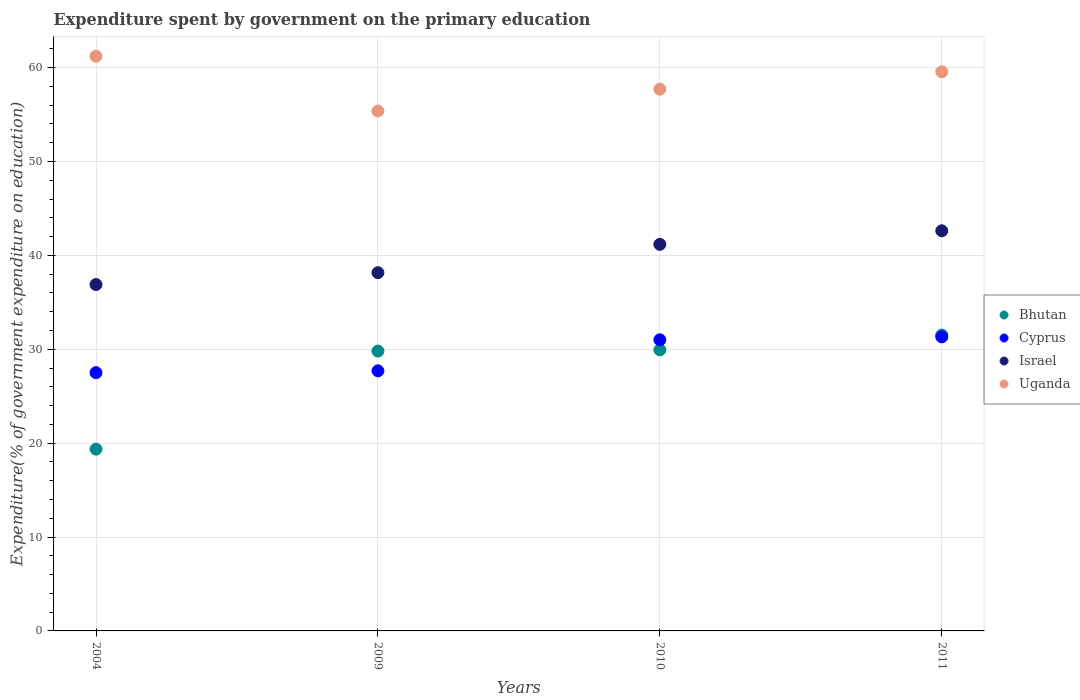What is the expenditure spent by government on the primary education in Uganda in 2004?
Provide a succinct answer. 61.21. Across all years, what is the maximum expenditure spent by government on the primary education in Uganda?
Provide a short and direct response. 61.21. Across all years, what is the minimum expenditure spent by government on the primary education in Israel?
Provide a short and direct response. 36.89. What is the total expenditure spent by government on the primary education in Uganda in the graph?
Ensure brevity in your answer.  233.84. What is the difference between the expenditure spent by government on the primary education in Bhutan in 2004 and that in 2009?
Give a very brief answer. -10.44. What is the difference between the expenditure spent by government on the primary education in Bhutan in 2009 and the expenditure spent by government on the primary education in Israel in 2010?
Ensure brevity in your answer.  -11.37. What is the average expenditure spent by government on the primary education in Israel per year?
Keep it short and to the point. 39.71. In the year 2011, what is the difference between the expenditure spent by government on the primary education in Cyprus and expenditure spent by government on the primary education in Uganda?
Make the answer very short. -28.23. In how many years, is the expenditure spent by government on the primary education in Bhutan greater than 14 %?
Provide a succinct answer. 4. What is the ratio of the expenditure spent by government on the primary education in Cyprus in 2009 to that in 2011?
Provide a short and direct response. 0.88. What is the difference between the highest and the second highest expenditure spent by government on the primary education in Israel?
Offer a very short reply. 1.44. What is the difference between the highest and the lowest expenditure spent by government on the primary education in Uganda?
Your answer should be compact. 5.84. Is it the case that in every year, the sum of the expenditure spent by government on the primary education in Uganda and expenditure spent by government on the primary education in Bhutan  is greater than the expenditure spent by government on the primary education in Israel?
Offer a very short reply. Yes. How many dotlines are there?
Your answer should be compact. 4. How many years are there in the graph?
Ensure brevity in your answer.  4. What is the difference between two consecutive major ticks on the Y-axis?
Provide a short and direct response. 10. Are the values on the major ticks of Y-axis written in scientific E-notation?
Offer a terse response. No. Does the graph contain any zero values?
Provide a succinct answer. No. Where does the legend appear in the graph?
Your answer should be very brief. Center right. What is the title of the graph?
Provide a succinct answer. Expenditure spent by government on the primary education. What is the label or title of the X-axis?
Make the answer very short. Years. What is the label or title of the Y-axis?
Provide a short and direct response. Expenditure(% of government expenditure on education). What is the Expenditure(% of government expenditure on education) in Bhutan in 2004?
Offer a terse response. 19.36. What is the Expenditure(% of government expenditure on education) in Cyprus in 2004?
Your response must be concise. 27.51. What is the Expenditure(% of government expenditure on education) of Israel in 2004?
Give a very brief answer. 36.89. What is the Expenditure(% of government expenditure on education) in Uganda in 2004?
Make the answer very short. 61.21. What is the Expenditure(% of government expenditure on education) of Bhutan in 2009?
Your answer should be very brief. 29.8. What is the Expenditure(% of government expenditure on education) in Cyprus in 2009?
Your response must be concise. 27.7. What is the Expenditure(% of government expenditure on education) in Israel in 2009?
Your response must be concise. 38.16. What is the Expenditure(% of government expenditure on education) of Uganda in 2009?
Provide a short and direct response. 55.38. What is the Expenditure(% of government expenditure on education) of Bhutan in 2010?
Offer a very short reply. 29.93. What is the Expenditure(% of government expenditure on education) in Cyprus in 2010?
Make the answer very short. 31.01. What is the Expenditure(% of government expenditure on education) of Israel in 2010?
Keep it short and to the point. 41.17. What is the Expenditure(% of government expenditure on education) of Uganda in 2010?
Offer a terse response. 57.7. What is the Expenditure(% of government expenditure on education) in Bhutan in 2011?
Ensure brevity in your answer.  31.51. What is the Expenditure(% of government expenditure on education) in Cyprus in 2011?
Provide a succinct answer. 31.32. What is the Expenditure(% of government expenditure on education) in Israel in 2011?
Provide a short and direct response. 42.62. What is the Expenditure(% of government expenditure on education) of Uganda in 2011?
Ensure brevity in your answer.  59.55. Across all years, what is the maximum Expenditure(% of government expenditure on education) in Bhutan?
Ensure brevity in your answer.  31.51. Across all years, what is the maximum Expenditure(% of government expenditure on education) of Cyprus?
Give a very brief answer. 31.32. Across all years, what is the maximum Expenditure(% of government expenditure on education) in Israel?
Give a very brief answer. 42.62. Across all years, what is the maximum Expenditure(% of government expenditure on education) of Uganda?
Ensure brevity in your answer.  61.21. Across all years, what is the minimum Expenditure(% of government expenditure on education) in Bhutan?
Provide a succinct answer. 19.36. Across all years, what is the minimum Expenditure(% of government expenditure on education) in Cyprus?
Your answer should be compact. 27.51. Across all years, what is the minimum Expenditure(% of government expenditure on education) in Israel?
Offer a very short reply. 36.89. Across all years, what is the minimum Expenditure(% of government expenditure on education) in Uganda?
Offer a very short reply. 55.38. What is the total Expenditure(% of government expenditure on education) of Bhutan in the graph?
Your response must be concise. 110.61. What is the total Expenditure(% of government expenditure on education) in Cyprus in the graph?
Give a very brief answer. 117.54. What is the total Expenditure(% of government expenditure on education) in Israel in the graph?
Provide a succinct answer. 158.84. What is the total Expenditure(% of government expenditure on education) in Uganda in the graph?
Your answer should be compact. 233.84. What is the difference between the Expenditure(% of government expenditure on education) of Bhutan in 2004 and that in 2009?
Give a very brief answer. -10.44. What is the difference between the Expenditure(% of government expenditure on education) of Cyprus in 2004 and that in 2009?
Make the answer very short. -0.19. What is the difference between the Expenditure(% of government expenditure on education) of Israel in 2004 and that in 2009?
Your response must be concise. -1.26. What is the difference between the Expenditure(% of government expenditure on education) in Uganda in 2004 and that in 2009?
Keep it short and to the point. 5.84. What is the difference between the Expenditure(% of government expenditure on education) of Bhutan in 2004 and that in 2010?
Keep it short and to the point. -10.57. What is the difference between the Expenditure(% of government expenditure on education) in Cyprus in 2004 and that in 2010?
Offer a terse response. -3.5. What is the difference between the Expenditure(% of government expenditure on education) in Israel in 2004 and that in 2010?
Keep it short and to the point. -4.28. What is the difference between the Expenditure(% of government expenditure on education) of Uganda in 2004 and that in 2010?
Provide a succinct answer. 3.51. What is the difference between the Expenditure(% of government expenditure on education) of Bhutan in 2004 and that in 2011?
Your answer should be very brief. -12.15. What is the difference between the Expenditure(% of government expenditure on education) in Cyprus in 2004 and that in 2011?
Provide a short and direct response. -3.82. What is the difference between the Expenditure(% of government expenditure on education) in Israel in 2004 and that in 2011?
Give a very brief answer. -5.73. What is the difference between the Expenditure(% of government expenditure on education) in Uganda in 2004 and that in 2011?
Provide a short and direct response. 1.66. What is the difference between the Expenditure(% of government expenditure on education) in Bhutan in 2009 and that in 2010?
Offer a terse response. -0.13. What is the difference between the Expenditure(% of government expenditure on education) in Cyprus in 2009 and that in 2010?
Provide a short and direct response. -3.31. What is the difference between the Expenditure(% of government expenditure on education) in Israel in 2009 and that in 2010?
Your answer should be compact. -3.02. What is the difference between the Expenditure(% of government expenditure on education) of Uganda in 2009 and that in 2010?
Make the answer very short. -2.33. What is the difference between the Expenditure(% of government expenditure on education) of Bhutan in 2009 and that in 2011?
Your answer should be compact. -1.71. What is the difference between the Expenditure(% of government expenditure on education) in Cyprus in 2009 and that in 2011?
Ensure brevity in your answer.  -3.62. What is the difference between the Expenditure(% of government expenditure on education) in Israel in 2009 and that in 2011?
Your response must be concise. -4.46. What is the difference between the Expenditure(% of government expenditure on education) of Uganda in 2009 and that in 2011?
Provide a short and direct response. -4.18. What is the difference between the Expenditure(% of government expenditure on education) in Bhutan in 2010 and that in 2011?
Give a very brief answer. -1.58. What is the difference between the Expenditure(% of government expenditure on education) in Cyprus in 2010 and that in 2011?
Offer a very short reply. -0.31. What is the difference between the Expenditure(% of government expenditure on education) of Israel in 2010 and that in 2011?
Offer a very short reply. -1.44. What is the difference between the Expenditure(% of government expenditure on education) in Uganda in 2010 and that in 2011?
Make the answer very short. -1.85. What is the difference between the Expenditure(% of government expenditure on education) of Bhutan in 2004 and the Expenditure(% of government expenditure on education) of Cyprus in 2009?
Your answer should be compact. -8.34. What is the difference between the Expenditure(% of government expenditure on education) in Bhutan in 2004 and the Expenditure(% of government expenditure on education) in Israel in 2009?
Ensure brevity in your answer.  -18.79. What is the difference between the Expenditure(% of government expenditure on education) of Bhutan in 2004 and the Expenditure(% of government expenditure on education) of Uganda in 2009?
Make the answer very short. -36.01. What is the difference between the Expenditure(% of government expenditure on education) in Cyprus in 2004 and the Expenditure(% of government expenditure on education) in Israel in 2009?
Your response must be concise. -10.65. What is the difference between the Expenditure(% of government expenditure on education) in Cyprus in 2004 and the Expenditure(% of government expenditure on education) in Uganda in 2009?
Ensure brevity in your answer.  -27.87. What is the difference between the Expenditure(% of government expenditure on education) in Israel in 2004 and the Expenditure(% of government expenditure on education) in Uganda in 2009?
Make the answer very short. -18.48. What is the difference between the Expenditure(% of government expenditure on education) in Bhutan in 2004 and the Expenditure(% of government expenditure on education) in Cyprus in 2010?
Offer a very short reply. -11.64. What is the difference between the Expenditure(% of government expenditure on education) in Bhutan in 2004 and the Expenditure(% of government expenditure on education) in Israel in 2010?
Your response must be concise. -21.81. What is the difference between the Expenditure(% of government expenditure on education) in Bhutan in 2004 and the Expenditure(% of government expenditure on education) in Uganda in 2010?
Your response must be concise. -38.34. What is the difference between the Expenditure(% of government expenditure on education) of Cyprus in 2004 and the Expenditure(% of government expenditure on education) of Israel in 2010?
Provide a short and direct response. -13.67. What is the difference between the Expenditure(% of government expenditure on education) of Cyprus in 2004 and the Expenditure(% of government expenditure on education) of Uganda in 2010?
Keep it short and to the point. -30.19. What is the difference between the Expenditure(% of government expenditure on education) of Israel in 2004 and the Expenditure(% of government expenditure on education) of Uganda in 2010?
Offer a terse response. -20.81. What is the difference between the Expenditure(% of government expenditure on education) of Bhutan in 2004 and the Expenditure(% of government expenditure on education) of Cyprus in 2011?
Ensure brevity in your answer.  -11.96. What is the difference between the Expenditure(% of government expenditure on education) in Bhutan in 2004 and the Expenditure(% of government expenditure on education) in Israel in 2011?
Offer a very short reply. -23.25. What is the difference between the Expenditure(% of government expenditure on education) of Bhutan in 2004 and the Expenditure(% of government expenditure on education) of Uganda in 2011?
Make the answer very short. -40.19. What is the difference between the Expenditure(% of government expenditure on education) in Cyprus in 2004 and the Expenditure(% of government expenditure on education) in Israel in 2011?
Make the answer very short. -15.11. What is the difference between the Expenditure(% of government expenditure on education) in Cyprus in 2004 and the Expenditure(% of government expenditure on education) in Uganda in 2011?
Offer a very short reply. -32.05. What is the difference between the Expenditure(% of government expenditure on education) in Israel in 2004 and the Expenditure(% of government expenditure on education) in Uganda in 2011?
Offer a terse response. -22.66. What is the difference between the Expenditure(% of government expenditure on education) in Bhutan in 2009 and the Expenditure(% of government expenditure on education) in Cyprus in 2010?
Your response must be concise. -1.2. What is the difference between the Expenditure(% of government expenditure on education) of Bhutan in 2009 and the Expenditure(% of government expenditure on education) of Israel in 2010?
Provide a short and direct response. -11.37. What is the difference between the Expenditure(% of government expenditure on education) of Bhutan in 2009 and the Expenditure(% of government expenditure on education) of Uganda in 2010?
Keep it short and to the point. -27.9. What is the difference between the Expenditure(% of government expenditure on education) in Cyprus in 2009 and the Expenditure(% of government expenditure on education) in Israel in 2010?
Your answer should be very brief. -13.47. What is the difference between the Expenditure(% of government expenditure on education) in Cyprus in 2009 and the Expenditure(% of government expenditure on education) in Uganda in 2010?
Your answer should be compact. -30. What is the difference between the Expenditure(% of government expenditure on education) of Israel in 2009 and the Expenditure(% of government expenditure on education) of Uganda in 2010?
Your response must be concise. -19.54. What is the difference between the Expenditure(% of government expenditure on education) of Bhutan in 2009 and the Expenditure(% of government expenditure on education) of Cyprus in 2011?
Offer a very short reply. -1.52. What is the difference between the Expenditure(% of government expenditure on education) of Bhutan in 2009 and the Expenditure(% of government expenditure on education) of Israel in 2011?
Your response must be concise. -12.81. What is the difference between the Expenditure(% of government expenditure on education) in Bhutan in 2009 and the Expenditure(% of government expenditure on education) in Uganda in 2011?
Your answer should be compact. -29.75. What is the difference between the Expenditure(% of government expenditure on education) of Cyprus in 2009 and the Expenditure(% of government expenditure on education) of Israel in 2011?
Make the answer very short. -14.92. What is the difference between the Expenditure(% of government expenditure on education) in Cyprus in 2009 and the Expenditure(% of government expenditure on education) in Uganda in 2011?
Make the answer very short. -31.85. What is the difference between the Expenditure(% of government expenditure on education) of Israel in 2009 and the Expenditure(% of government expenditure on education) of Uganda in 2011?
Your response must be concise. -21.4. What is the difference between the Expenditure(% of government expenditure on education) of Bhutan in 2010 and the Expenditure(% of government expenditure on education) of Cyprus in 2011?
Your answer should be compact. -1.39. What is the difference between the Expenditure(% of government expenditure on education) in Bhutan in 2010 and the Expenditure(% of government expenditure on education) in Israel in 2011?
Offer a very short reply. -12.68. What is the difference between the Expenditure(% of government expenditure on education) of Bhutan in 2010 and the Expenditure(% of government expenditure on education) of Uganda in 2011?
Your answer should be very brief. -29.62. What is the difference between the Expenditure(% of government expenditure on education) in Cyprus in 2010 and the Expenditure(% of government expenditure on education) in Israel in 2011?
Offer a very short reply. -11.61. What is the difference between the Expenditure(% of government expenditure on education) of Cyprus in 2010 and the Expenditure(% of government expenditure on education) of Uganda in 2011?
Provide a short and direct response. -28.54. What is the difference between the Expenditure(% of government expenditure on education) of Israel in 2010 and the Expenditure(% of government expenditure on education) of Uganda in 2011?
Keep it short and to the point. -18.38. What is the average Expenditure(% of government expenditure on education) in Bhutan per year?
Keep it short and to the point. 27.65. What is the average Expenditure(% of government expenditure on education) of Cyprus per year?
Offer a very short reply. 29.38. What is the average Expenditure(% of government expenditure on education) of Israel per year?
Make the answer very short. 39.71. What is the average Expenditure(% of government expenditure on education) of Uganda per year?
Keep it short and to the point. 58.46. In the year 2004, what is the difference between the Expenditure(% of government expenditure on education) of Bhutan and Expenditure(% of government expenditure on education) of Cyprus?
Your answer should be compact. -8.14. In the year 2004, what is the difference between the Expenditure(% of government expenditure on education) in Bhutan and Expenditure(% of government expenditure on education) in Israel?
Offer a very short reply. -17.53. In the year 2004, what is the difference between the Expenditure(% of government expenditure on education) of Bhutan and Expenditure(% of government expenditure on education) of Uganda?
Your answer should be compact. -41.85. In the year 2004, what is the difference between the Expenditure(% of government expenditure on education) in Cyprus and Expenditure(% of government expenditure on education) in Israel?
Provide a succinct answer. -9.39. In the year 2004, what is the difference between the Expenditure(% of government expenditure on education) of Cyprus and Expenditure(% of government expenditure on education) of Uganda?
Your answer should be very brief. -33.7. In the year 2004, what is the difference between the Expenditure(% of government expenditure on education) in Israel and Expenditure(% of government expenditure on education) in Uganda?
Provide a succinct answer. -24.32. In the year 2009, what is the difference between the Expenditure(% of government expenditure on education) of Bhutan and Expenditure(% of government expenditure on education) of Cyprus?
Ensure brevity in your answer.  2.1. In the year 2009, what is the difference between the Expenditure(% of government expenditure on education) of Bhutan and Expenditure(% of government expenditure on education) of Israel?
Ensure brevity in your answer.  -8.35. In the year 2009, what is the difference between the Expenditure(% of government expenditure on education) of Bhutan and Expenditure(% of government expenditure on education) of Uganda?
Offer a terse response. -25.57. In the year 2009, what is the difference between the Expenditure(% of government expenditure on education) in Cyprus and Expenditure(% of government expenditure on education) in Israel?
Your answer should be compact. -10.46. In the year 2009, what is the difference between the Expenditure(% of government expenditure on education) of Cyprus and Expenditure(% of government expenditure on education) of Uganda?
Provide a succinct answer. -27.68. In the year 2009, what is the difference between the Expenditure(% of government expenditure on education) in Israel and Expenditure(% of government expenditure on education) in Uganda?
Ensure brevity in your answer.  -17.22. In the year 2010, what is the difference between the Expenditure(% of government expenditure on education) in Bhutan and Expenditure(% of government expenditure on education) in Cyprus?
Make the answer very short. -1.07. In the year 2010, what is the difference between the Expenditure(% of government expenditure on education) in Bhutan and Expenditure(% of government expenditure on education) in Israel?
Ensure brevity in your answer.  -11.24. In the year 2010, what is the difference between the Expenditure(% of government expenditure on education) of Bhutan and Expenditure(% of government expenditure on education) of Uganda?
Make the answer very short. -27.77. In the year 2010, what is the difference between the Expenditure(% of government expenditure on education) of Cyprus and Expenditure(% of government expenditure on education) of Israel?
Ensure brevity in your answer.  -10.17. In the year 2010, what is the difference between the Expenditure(% of government expenditure on education) in Cyprus and Expenditure(% of government expenditure on education) in Uganda?
Give a very brief answer. -26.69. In the year 2010, what is the difference between the Expenditure(% of government expenditure on education) in Israel and Expenditure(% of government expenditure on education) in Uganda?
Your answer should be compact. -16.53. In the year 2011, what is the difference between the Expenditure(% of government expenditure on education) of Bhutan and Expenditure(% of government expenditure on education) of Cyprus?
Ensure brevity in your answer.  0.19. In the year 2011, what is the difference between the Expenditure(% of government expenditure on education) in Bhutan and Expenditure(% of government expenditure on education) in Israel?
Your answer should be very brief. -11.11. In the year 2011, what is the difference between the Expenditure(% of government expenditure on education) of Bhutan and Expenditure(% of government expenditure on education) of Uganda?
Your answer should be compact. -28.04. In the year 2011, what is the difference between the Expenditure(% of government expenditure on education) of Cyprus and Expenditure(% of government expenditure on education) of Israel?
Ensure brevity in your answer.  -11.3. In the year 2011, what is the difference between the Expenditure(% of government expenditure on education) of Cyprus and Expenditure(% of government expenditure on education) of Uganda?
Your answer should be very brief. -28.23. In the year 2011, what is the difference between the Expenditure(% of government expenditure on education) of Israel and Expenditure(% of government expenditure on education) of Uganda?
Make the answer very short. -16.93. What is the ratio of the Expenditure(% of government expenditure on education) of Bhutan in 2004 to that in 2009?
Your response must be concise. 0.65. What is the ratio of the Expenditure(% of government expenditure on education) of Israel in 2004 to that in 2009?
Give a very brief answer. 0.97. What is the ratio of the Expenditure(% of government expenditure on education) in Uganda in 2004 to that in 2009?
Offer a terse response. 1.11. What is the ratio of the Expenditure(% of government expenditure on education) in Bhutan in 2004 to that in 2010?
Make the answer very short. 0.65. What is the ratio of the Expenditure(% of government expenditure on education) in Cyprus in 2004 to that in 2010?
Provide a short and direct response. 0.89. What is the ratio of the Expenditure(% of government expenditure on education) of Israel in 2004 to that in 2010?
Offer a very short reply. 0.9. What is the ratio of the Expenditure(% of government expenditure on education) of Uganda in 2004 to that in 2010?
Offer a very short reply. 1.06. What is the ratio of the Expenditure(% of government expenditure on education) in Bhutan in 2004 to that in 2011?
Offer a terse response. 0.61. What is the ratio of the Expenditure(% of government expenditure on education) of Cyprus in 2004 to that in 2011?
Provide a short and direct response. 0.88. What is the ratio of the Expenditure(% of government expenditure on education) of Israel in 2004 to that in 2011?
Offer a very short reply. 0.87. What is the ratio of the Expenditure(% of government expenditure on education) in Uganda in 2004 to that in 2011?
Provide a short and direct response. 1.03. What is the ratio of the Expenditure(% of government expenditure on education) in Cyprus in 2009 to that in 2010?
Keep it short and to the point. 0.89. What is the ratio of the Expenditure(% of government expenditure on education) in Israel in 2009 to that in 2010?
Your answer should be very brief. 0.93. What is the ratio of the Expenditure(% of government expenditure on education) in Uganda in 2009 to that in 2010?
Make the answer very short. 0.96. What is the ratio of the Expenditure(% of government expenditure on education) in Bhutan in 2009 to that in 2011?
Give a very brief answer. 0.95. What is the ratio of the Expenditure(% of government expenditure on education) of Cyprus in 2009 to that in 2011?
Provide a short and direct response. 0.88. What is the ratio of the Expenditure(% of government expenditure on education) of Israel in 2009 to that in 2011?
Your response must be concise. 0.9. What is the ratio of the Expenditure(% of government expenditure on education) in Uganda in 2009 to that in 2011?
Make the answer very short. 0.93. What is the ratio of the Expenditure(% of government expenditure on education) in Bhutan in 2010 to that in 2011?
Give a very brief answer. 0.95. What is the ratio of the Expenditure(% of government expenditure on education) in Israel in 2010 to that in 2011?
Your response must be concise. 0.97. What is the ratio of the Expenditure(% of government expenditure on education) in Uganda in 2010 to that in 2011?
Provide a short and direct response. 0.97. What is the difference between the highest and the second highest Expenditure(% of government expenditure on education) in Bhutan?
Provide a succinct answer. 1.58. What is the difference between the highest and the second highest Expenditure(% of government expenditure on education) of Cyprus?
Your answer should be very brief. 0.31. What is the difference between the highest and the second highest Expenditure(% of government expenditure on education) of Israel?
Give a very brief answer. 1.44. What is the difference between the highest and the second highest Expenditure(% of government expenditure on education) of Uganda?
Keep it short and to the point. 1.66. What is the difference between the highest and the lowest Expenditure(% of government expenditure on education) of Bhutan?
Your answer should be very brief. 12.15. What is the difference between the highest and the lowest Expenditure(% of government expenditure on education) in Cyprus?
Offer a very short reply. 3.82. What is the difference between the highest and the lowest Expenditure(% of government expenditure on education) of Israel?
Provide a succinct answer. 5.73. What is the difference between the highest and the lowest Expenditure(% of government expenditure on education) of Uganda?
Give a very brief answer. 5.84. 